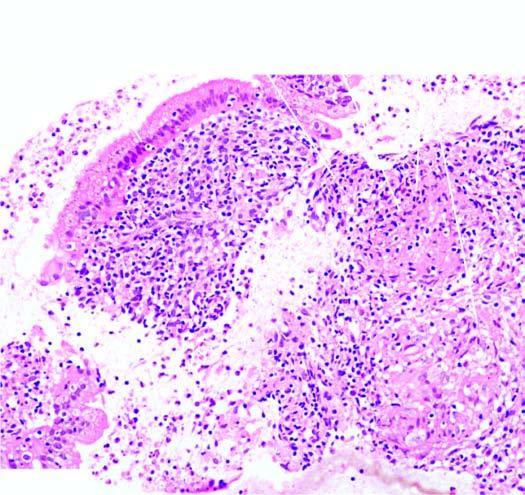what has the stroma caseating?
Answer the question using a single word or phrase. Epithelioid cell granulomas having langhans 'giant cells and peripheral layer of lymphocytes 